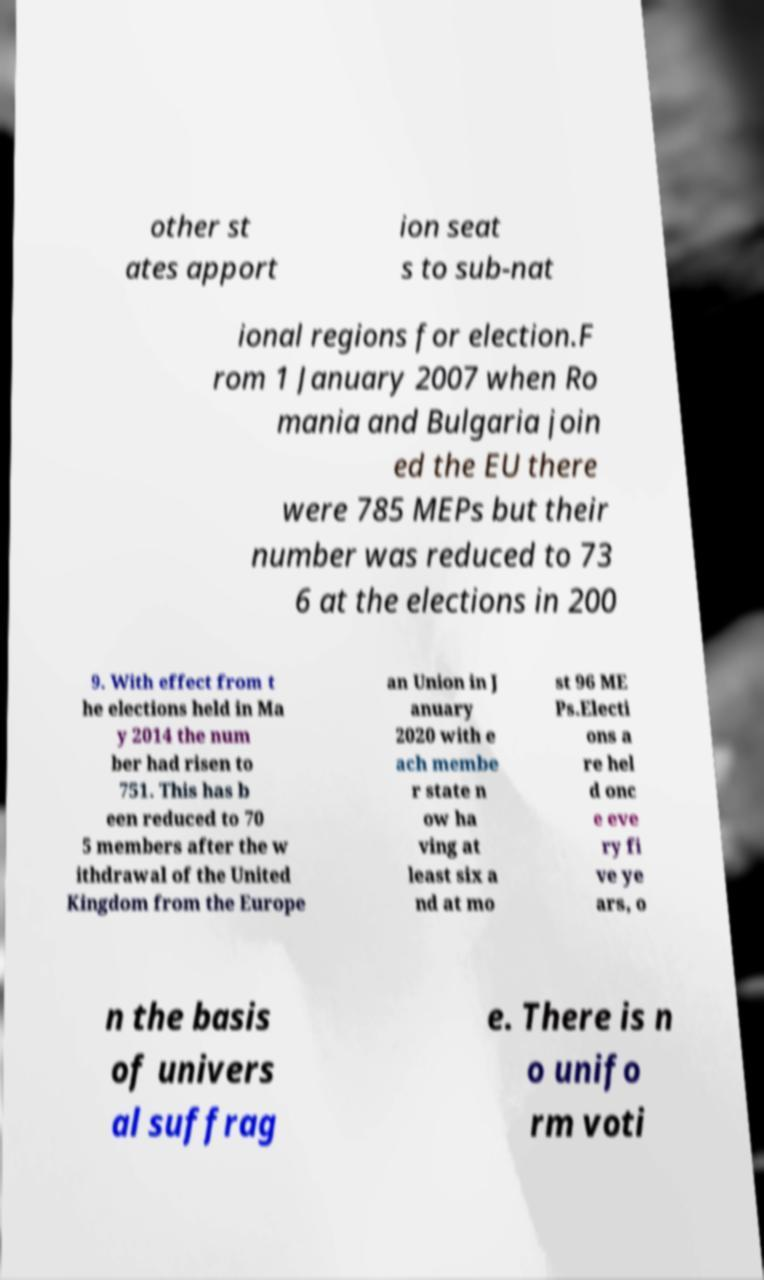I need the written content from this picture converted into text. Can you do that? other st ates apport ion seat s to sub-nat ional regions for election.F rom 1 January 2007 when Ro mania and Bulgaria join ed the EU there were 785 MEPs but their number was reduced to 73 6 at the elections in 200 9. With effect from t he elections held in Ma y 2014 the num ber had risen to 751. This has b een reduced to 70 5 members after the w ithdrawal of the United Kingdom from the Europe an Union in J anuary 2020 with e ach membe r state n ow ha ving at least six a nd at mo st 96 ME Ps.Electi ons a re hel d onc e eve ry fi ve ye ars, o n the basis of univers al suffrag e. There is n o unifo rm voti 